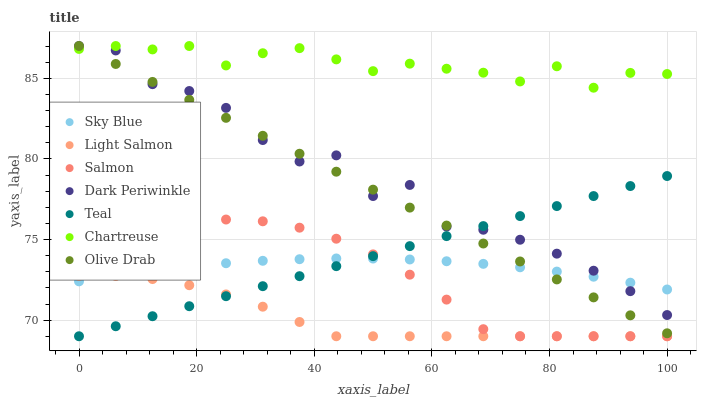Does Light Salmon have the minimum area under the curve?
Answer yes or no. Yes. Does Chartreuse have the maximum area under the curve?
Answer yes or no. Yes. Does Salmon have the minimum area under the curve?
Answer yes or no. No. Does Salmon have the maximum area under the curve?
Answer yes or no. No. Is Olive Drab the smoothest?
Answer yes or no. Yes. Is Dark Periwinkle the roughest?
Answer yes or no. Yes. Is Salmon the smoothest?
Answer yes or no. No. Is Salmon the roughest?
Answer yes or no. No. Does Light Salmon have the lowest value?
Answer yes or no. Yes. Does Chartreuse have the lowest value?
Answer yes or no. No. Does Olive Drab have the highest value?
Answer yes or no. Yes. Does Salmon have the highest value?
Answer yes or no. No. Is Light Salmon less than Chartreuse?
Answer yes or no. Yes. Is Dark Periwinkle greater than Light Salmon?
Answer yes or no. Yes. Does Teal intersect Light Salmon?
Answer yes or no. Yes. Is Teal less than Light Salmon?
Answer yes or no. No. Is Teal greater than Light Salmon?
Answer yes or no. No. Does Light Salmon intersect Chartreuse?
Answer yes or no. No. 